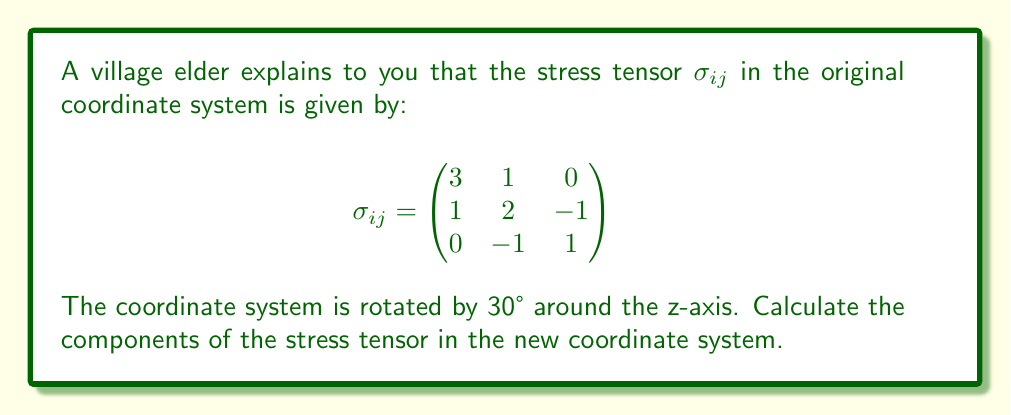Could you help me with this problem? To solve this problem, we'll follow these steps:

1) First, we need to recall the transformation rule for second-order tensors:

   $$\sigma'_{ij} = a_{im} a_{jn} \sigma_{mn}$$

   where $a_{im}$ and $a_{jn}$ are components of the rotation matrix.

2) For a rotation of $\theta = 30°$ around the z-axis, the rotation matrix is:

   $$A = \begin{pmatrix}
   \cos\theta & -\sin\theta & 0 \\
   \sin\theta & \cos\theta & 0 \\
   0 & 0 & 1
   \end{pmatrix} = \begin{pmatrix}
   \frac{\sqrt{3}}{2} & -\frac{1}{2} & 0 \\
   \frac{1}{2} & \frac{\sqrt{3}}{2} & 0 \\
   0 & 0 & 1
   \end{pmatrix}$$

3) Now, we apply the transformation rule. For example, for $\sigma'_{11}$:

   $$\sigma'_{11} = a_{1m} a_{1n} \sigma_{mn} = (a_{11})^2 \sigma_{11} + (a_{12})^2 \sigma_{22} + 2a_{11}a_{12}\sigma_{12}$$

4) Substituting the values:

   $$\sigma'_{11} = (\frac{\sqrt{3}}{2})^2 \cdot 3 + (-\frac{1}{2})^2 \cdot 2 + 2 \cdot \frac{\sqrt{3}}{2} \cdot (-\frac{1}{2}) \cdot 1 = \frac{9}{4} + \frac{1}{4} - \frac{\sqrt{3}}{2} = \frac{5}{2} - \frac{\sqrt{3}}{2}$$

5) We repeat this process for all components of $\sigma'_{ij}$. The resulting tensor is:

   $$\sigma'_{ij} = \begin{pmatrix}
   \frac{5}{2} - \frac{\sqrt{3}}{2} & \frac{1}{2} + \frac{\sqrt{3}}{2} & -\frac{1}{2} \\
   \frac{1}{2} + \frac{\sqrt{3}}{2} & \frac{5}{2} + \frac{\sqrt{3}}{2} & -\frac{\sqrt{3}}{2} \\
   -\frac{1}{2} & -\frac{\sqrt{3}}{2} & 1
   \end{pmatrix}$$
Answer: $$\sigma'_{ij} = \begin{pmatrix}
\frac{5}{2} - \frac{\sqrt{3}}{2} & \frac{1}{2} + \frac{\sqrt{3}}{2} & -\frac{1}{2} \\
\frac{1}{2} + \frac{\sqrt{3}}{2} & \frac{5}{2} + \frac{\sqrt{3}}{2} & -\frac{\sqrt{3}}{2} \\
-\frac{1}{2} & -\frac{\sqrt{3}}{2} & 1
\end{pmatrix}$$ 